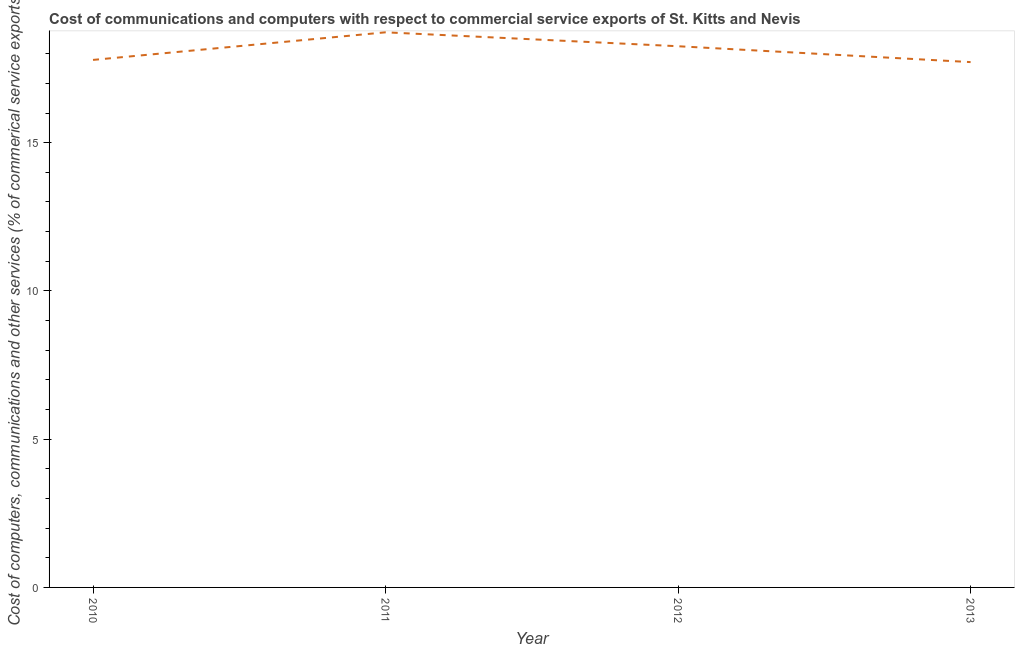What is the cost of communications in 2011?
Give a very brief answer. 18.72. Across all years, what is the maximum cost of communications?
Give a very brief answer. 18.72. Across all years, what is the minimum  computer and other services?
Make the answer very short. 17.72. In which year was the  computer and other services maximum?
Keep it short and to the point. 2011. In which year was the cost of communications minimum?
Make the answer very short. 2013. What is the sum of the cost of communications?
Ensure brevity in your answer.  72.48. What is the difference between the  computer and other services in 2011 and 2012?
Ensure brevity in your answer.  0.47. What is the average cost of communications per year?
Keep it short and to the point. 18.12. What is the median cost of communications?
Offer a terse response. 18.02. Do a majority of the years between 2011 and 2012 (inclusive) have  computer and other services greater than 15 %?
Your response must be concise. Yes. What is the ratio of the  computer and other services in 2011 to that in 2013?
Provide a succinct answer. 1.06. Is the  computer and other services in 2010 less than that in 2011?
Give a very brief answer. Yes. What is the difference between the highest and the second highest  computer and other services?
Keep it short and to the point. 0.47. Is the sum of the cost of communications in 2011 and 2012 greater than the maximum cost of communications across all years?
Provide a short and direct response. Yes. What is the difference between the highest and the lowest cost of communications?
Your response must be concise. 1. In how many years, is the cost of communications greater than the average cost of communications taken over all years?
Your answer should be compact. 2. How many lines are there?
Ensure brevity in your answer.  1. Does the graph contain any zero values?
Your answer should be compact. No. What is the title of the graph?
Your response must be concise. Cost of communications and computers with respect to commercial service exports of St. Kitts and Nevis. What is the label or title of the Y-axis?
Your answer should be compact. Cost of computers, communications and other services (% of commerical service exports). What is the Cost of computers, communications and other services (% of commerical service exports) of 2010?
Offer a terse response. 17.79. What is the Cost of computers, communications and other services (% of commerical service exports) of 2011?
Offer a very short reply. 18.72. What is the Cost of computers, communications and other services (% of commerical service exports) of 2012?
Keep it short and to the point. 18.25. What is the Cost of computers, communications and other services (% of commerical service exports) in 2013?
Your answer should be compact. 17.72. What is the difference between the Cost of computers, communications and other services (% of commerical service exports) in 2010 and 2011?
Offer a terse response. -0.93. What is the difference between the Cost of computers, communications and other services (% of commerical service exports) in 2010 and 2012?
Make the answer very short. -0.46. What is the difference between the Cost of computers, communications and other services (% of commerical service exports) in 2010 and 2013?
Provide a succinct answer. 0.07. What is the difference between the Cost of computers, communications and other services (% of commerical service exports) in 2011 and 2012?
Keep it short and to the point. 0.47. What is the difference between the Cost of computers, communications and other services (% of commerical service exports) in 2011 and 2013?
Provide a succinct answer. 1. What is the difference between the Cost of computers, communications and other services (% of commerical service exports) in 2012 and 2013?
Offer a very short reply. 0.54. What is the ratio of the Cost of computers, communications and other services (% of commerical service exports) in 2010 to that in 2012?
Ensure brevity in your answer.  0.97. What is the ratio of the Cost of computers, communications and other services (% of commerical service exports) in 2011 to that in 2013?
Offer a terse response. 1.06. What is the ratio of the Cost of computers, communications and other services (% of commerical service exports) in 2012 to that in 2013?
Provide a short and direct response. 1.03. 